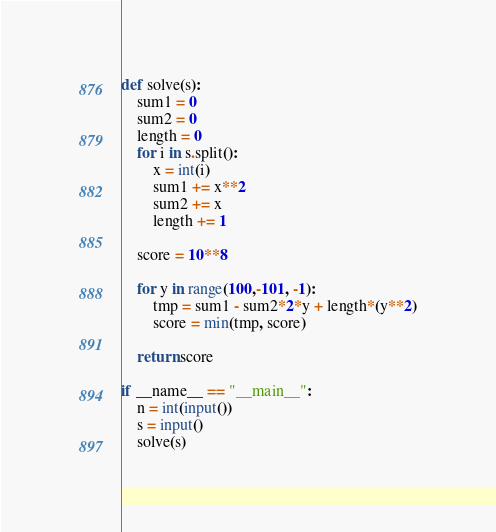<code> <loc_0><loc_0><loc_500><loc_500><_Python_>def solve(s):
    sum1 = 0
    sum2 = 0
    length = 0
    for i in s.split():
        x = int(i)
        sum1 += x**2
        sum2 += x
        length += 1

    score = 10**8

    for y in range(100,-101, -1):
        tmp = sum1 - sum2*2*y + length*(y**2)
        score = min(tmp, score)

    return score

if __name__ == "__main__":
    n = int(input())
    s = input()
    solve(s)</code> 